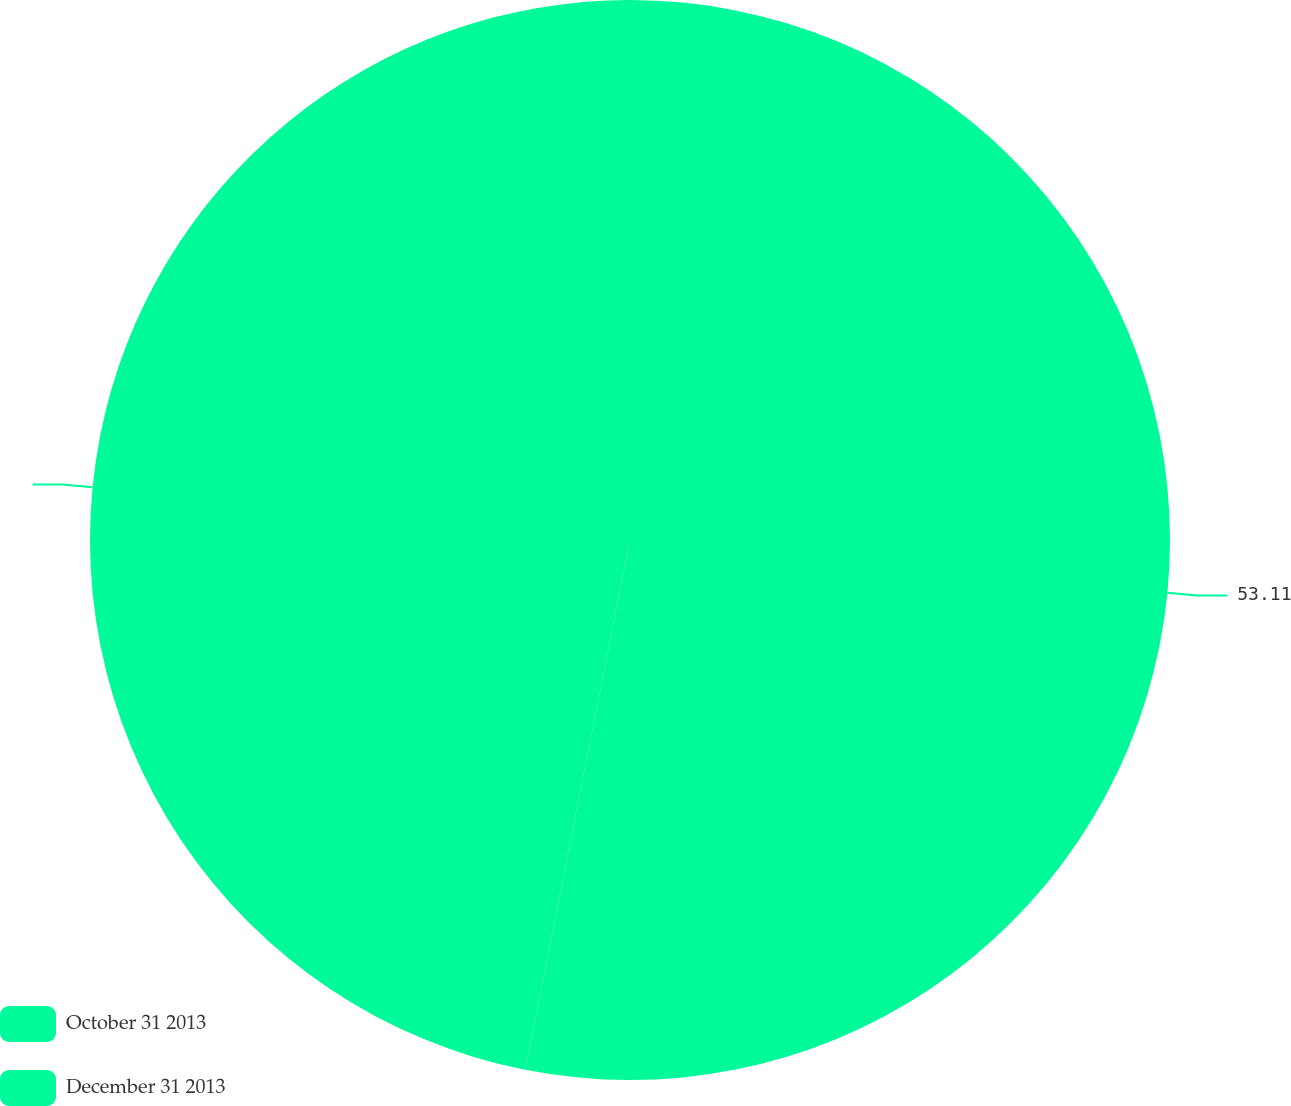<chart> <loc_0><loc_0><loc_500><loc_500><pie_chart><fcel>October 31 2013<fcel>December 31 2013<nl><fcel>53.11%<fcel>46.89%<nl></chart> 